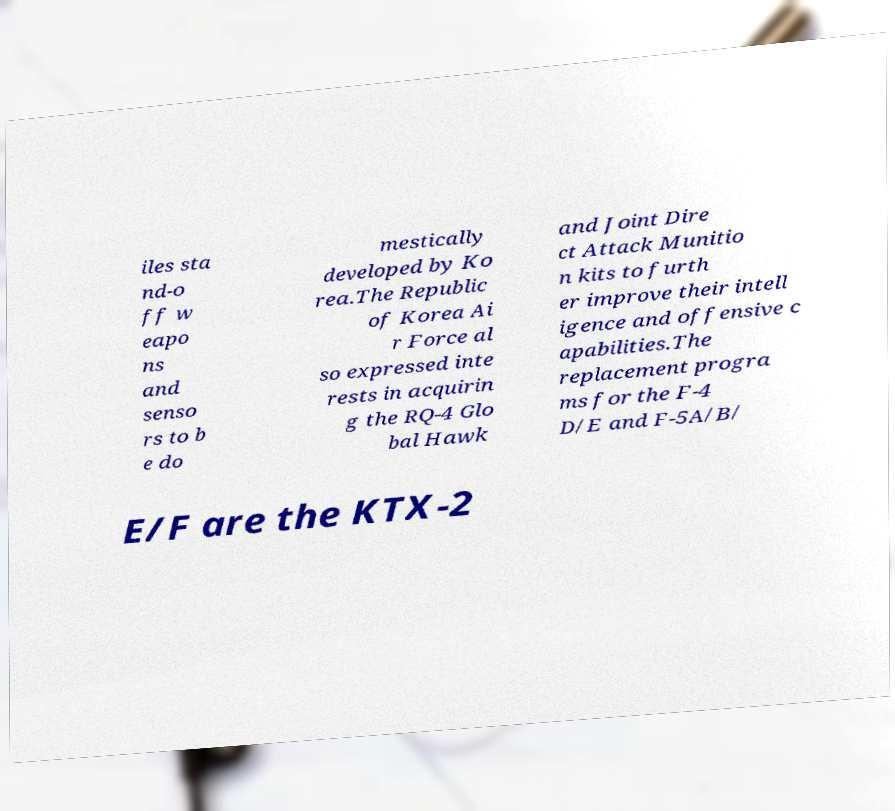Can you accurately transcribe the text from the provided image for me? iles sta nd-o ff w eapo ns and senso rs to b e do mestically developed by Ko rea.The Republic of Korea Ai r Force al so expressed inte rests in acquirin g the RQ-4 Glo bal Hawk and Joint Dire ct Attack Munitio n kits to furth er improve their intell igence and offensive c apabilities.The replacement progra ms for the F-4 D/E and F-5A/B/ E/F are the KTX-2 